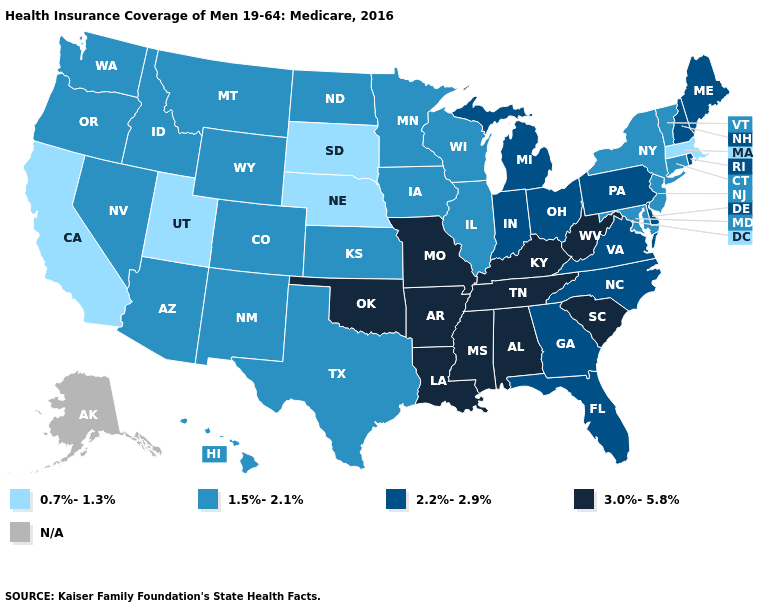Among the states that border Nebraska , does Kansas have the lowest value?
Give a very brief answer. No. What is the lowest value in the MidWest?
Answer briefly. 0.7%-1.3%. Among the states that border Rhode Island , which have the highest value?
Keep it brief. Connecticut. Which states have the lowest value in the West?
Short answer required. California, Utah. Name the states that have a value in the range 3.0%-5.8%?
Answer briefly. Alabama, Arkansas, Kentucky, Louisiana, Mississippi, Missouri, Oklahoma, South Carolina, Tennessee, West Virginia. What is the lowest value in the USA?
Write a very short answer. 0.7%-1.3%. Name the states that have a value in the range 3.0%-5.8%?
Write a very short answer. Alabama, Arkansas, Kentucky, Louisiana, Mississippi, Missouri, Oklahoma, South Carolina, Tennessee, West Virginia. What is the value of Arkansas?
Answer briefly. 3.0%-5.8%. Among the states that border South Dakota , does Wyoming have the lowest value?
Keep it brief. No. Is the legend a continuous bar?
Quick response, please. No. Which states have the highest value in the USA?
Concise answer only. Alabama, Arkansas, Kentucky, Louisiana, Mississippi, Missouri, Oklahoma, South Carolina, Tennessee, West Virginia. Which states hav the highest value in the South?
Keep it brief. Alabama, Arkansas, Kentucky, Louisiana, Mississippi, Oklahoma, South Carolina, Tennessee, West Virginia. Among the states that border Oregon , does Washington have the lowest value?
Quick response, please. No. What is the value of Arizona?
Write a very short answer. 1.5%-2.1%. What is the value of Alabama?
Answer briefly. 3.0%-5.8%. 